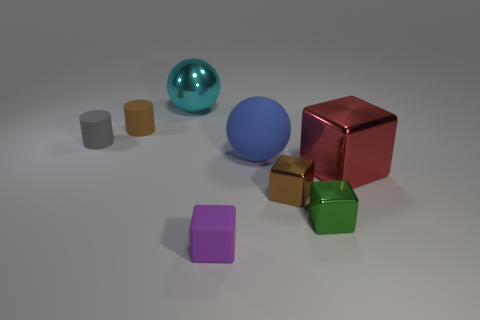There is a cube that is to the left of the blue thing; what is its size?
Your response must be concise. Small. Do the purple thing and the green object have the same size?
Ensure brevity in your answer.  Yes. How many things are either large things or tiny objects that are behind the blue matte object?
Your answer should be very brief. 5. What is the material of the tiny brown cylinder?
Offer a very short reply. Rubber. Do the gray matte thing and the brown rubber object have the same shape?
Offer a very short reply. Yes. There is a brown object that is behind the big metallic object that is in front of the large ball behind the large blue object; what size is it?
Offer a very short reply. Small. How many other things are there of the same material as the big cyan thing?
Provide a succinct answer. 3. What color is the small cylinder behind the small gray rubber thing?
Make the answer very short. Brown. What is the ball that is on the right side of the tiny block left of the small brown thing that is on the right side of the tiny brown matte cylinder made of?
Offer a very short reply. Rubber. Are there any small brown matte things of the same shape as the tiny gray thing?
Provide a succinct answer. Yes. 